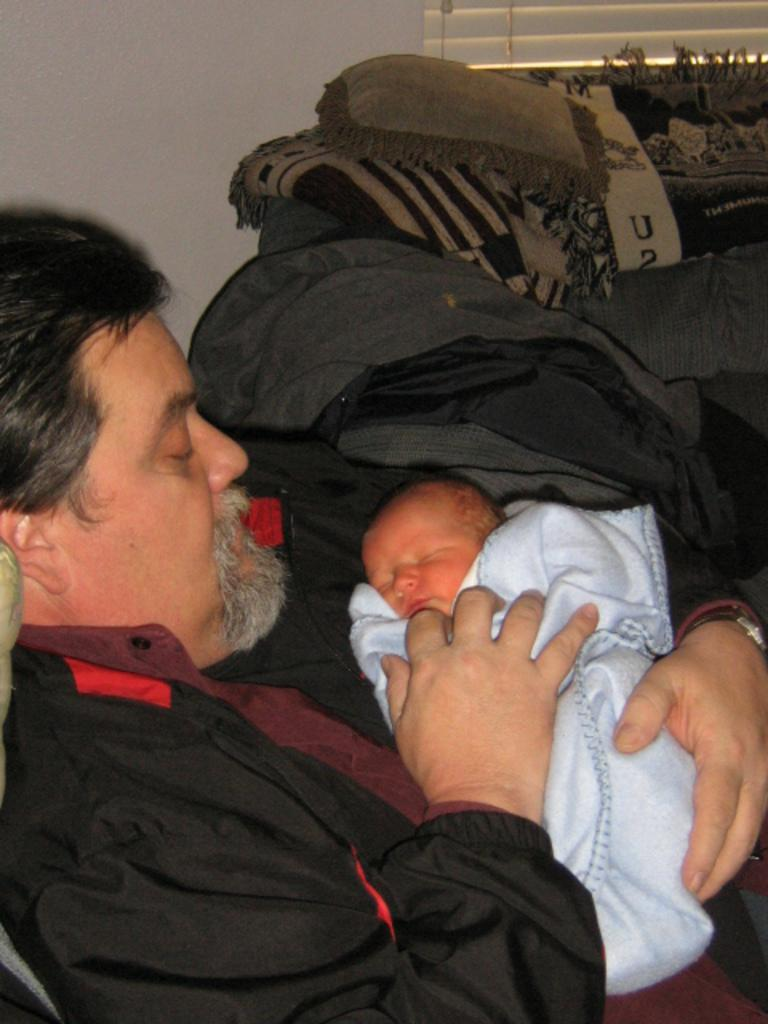Who is present in the image? There is a man in the image. What is the man doing in the image? The man is holding a baby. What is the man wearing in the image? The man is wearing a black coat. What is on the baby in the image? There is a white cloth on the baby. How many kittens are visible in the image? There are no kittens present in the image. What color are the man's toes in the image? The provided facts do not mention the man's toes, so we cannot determine their color from the image. 